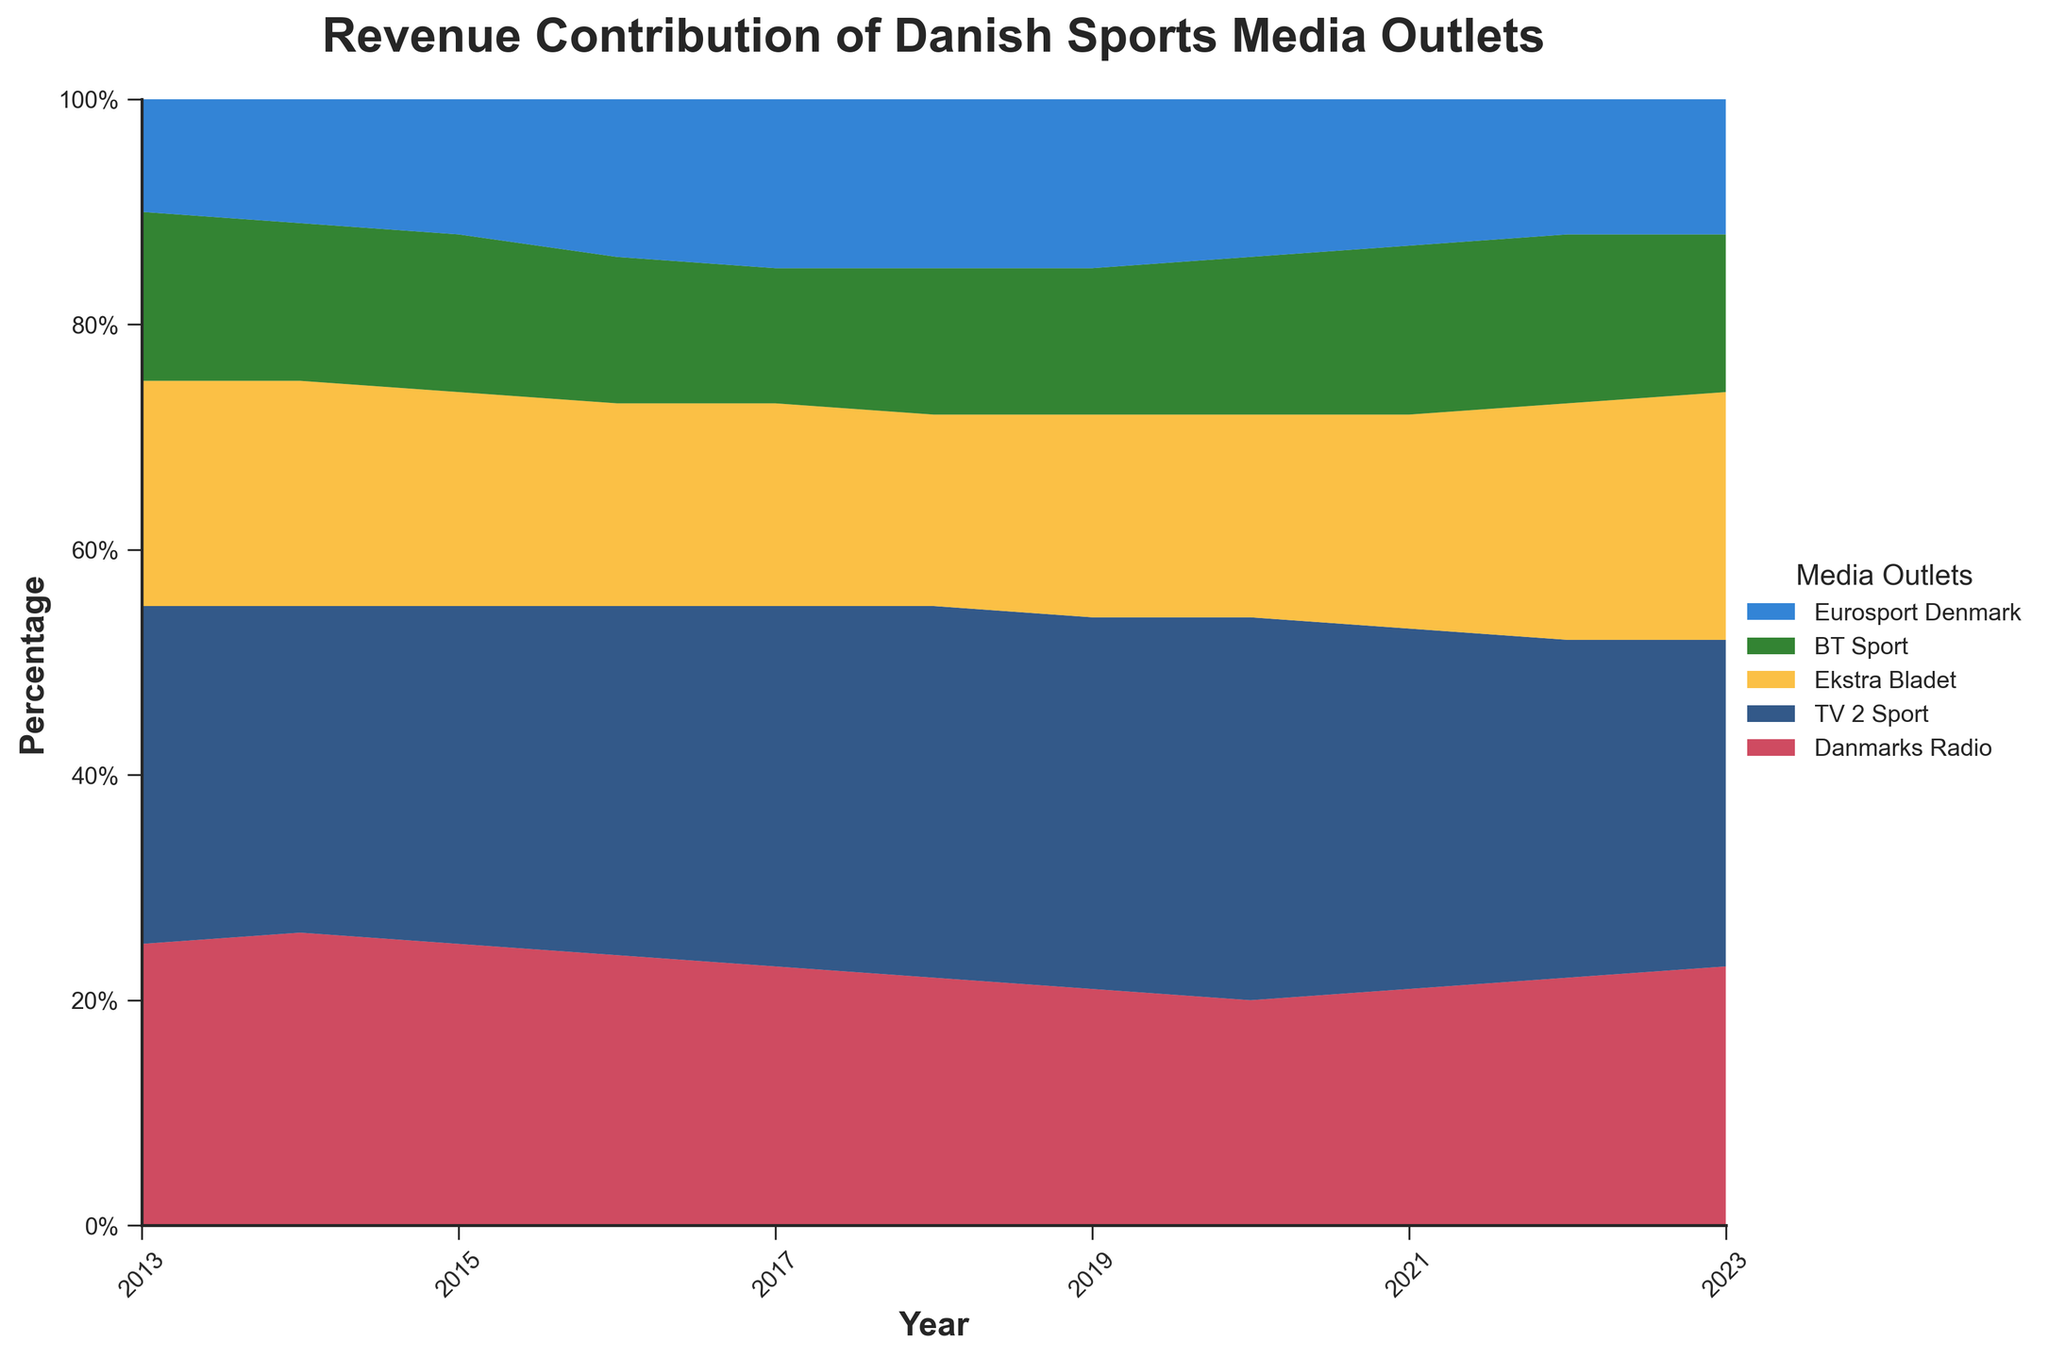What is the title of the figure? The title is located at the top of the figure. It provides an overview of what the chart is illustrating. Here, it reads "Revenue Contribution of Danish Sports Media Outlets".
Answer: Revenue Contribution of Danish Sports Media Outlets How does the contribution of Eurosport Denmark change over the years? Looking at the light blue area in the chart, we see that Eurosport Denmark's contribution increases from 2013 to 2017 and stabilizes through 2023.
Answer: Increases then stabilizes Which media outlet had the highest revenue contribution in 2020? By comparing the sizes of the stacked areas in 2020, we see that TV 2 Sport (colored in darker blue) has the largest segment.
Answer: TV 2 Sport What is the general trend of Danmarks Radio's revenue contribution over the last ten years? Observing the red section at the bottom of the chart, we notice that Danmarks Radio's revenue contribution decreases steadily from 25% in 2013 to around 20% in 2020 and then slightly increases up to 23% by 2023.
Answer: Decreases, then slightly increases Compare the revenue contributions of Ekstra Bladet and BT Sport in 2021. In 2021, Ekstra Bladet (in yellow) has a greater area than BT Sport (in green). Ekstra Bladet contributes 19%, and BT Sport contributes 15%.
Answer: Ekstra Bladet has a higher contribution What is the sum of revenue contributions of TV 2 Sport and Danmarks Radio in 2015? TV 2 Sport contributes 30% and Danmarks Radio contributes 25% in 2015. Summing up these contributions: 30% + 25% = 55%.
Answer: 55% Did any media outlet's revenue contribution surpass 35% at any point in the last ten years? Scanning through the chart, none of the areas exceed 35% at any given year. The highest contributions are around 34%.
Answer: No During which year did BT Sport have its highest revenue contribution, and what was the percentage? The green area representing BT Sport peaks around 2014. Checking the y-axis intersection, it is 15%.
Answer: 2014, 15% How do the revenue contributions of the five media outlets compare in 2018? In 2018, TV 2 Sport leads with 33%, followed by Danmarks Radio at 22%, Ekstra Bladet at 17%, BT Sport at 13%, and Eurosport Denmark also at 15%.
Answer: TV 2 Sport > Danmarks Radio > Ekstra Bladet > Eurosport Denmark = BT Sport 